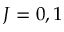Convert formula to latex. <formula><loc_0><loc_0><loc_500><loc_500>J = 0 , 1</formula> 